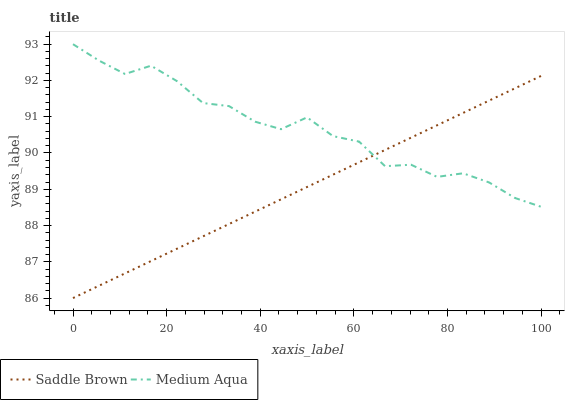Does Saddle Brown have the minimum area under the curve?
Answer yes or no. Yes. Does Medium Aqua have the maximum area under the curve?
Answer yes or no. Yes. Does Saddle Brown have the maximum area under the curve?
Answer yes or no. No. Is Saddle Brown the smoothest?
Answer yes or no. Yes. Is Medium Aqua the roughest?
Answer yes or no. Yes. Is Saddle Brown the roughest?
Answer yes or no. No. Does Saddle Brown have the lowest value?
Answer yes or no. Yes. Does Medium Aqua have the highest value?
Answer yes or no. Yes. Does Saddle Brown have the highest value?
Answer yes or no. No. Does Medium Aqua intersect Saddle Brown?
Answer yes or no. Yes. Is Medium Aqua less than Saddle Brown?
Answer yes or no. No. Is Medium Aqua greater than Saddle Brown?
Answer yes or no. No. 